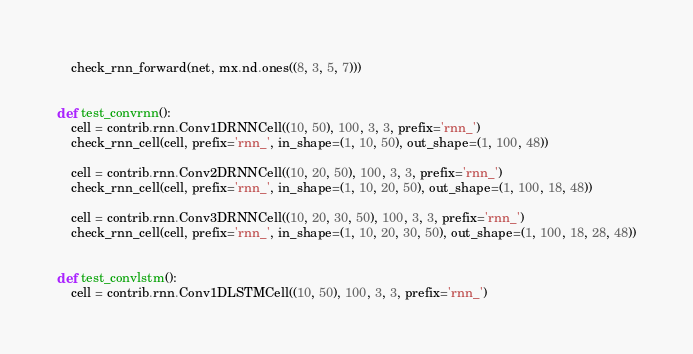<code> <loc_0><loc_0><loc_500><loc_500><_Python_>    check_rnn_forward(net, mx.nd.ones((8, 3, 5, 7)))


def test_convrnn():
    cell = contrib.rnn.Conv1DRNNCell((10, 50), 100, 3, 3, prefix='rnn_')
    check_rnn_cell(cell, prefix='rnn_', in_shape=(1, 10, 50), out_shape=(1, 100, 48))

    cell = contrib.rnn.Conv2DRNNCell((10, 20, 50), 100, 3, 3, prefix='rnn_')
    check_rnn_cell(cell, prefix='rnn_', in_shape=(1, 10, 20, 50), out_shape=(1, 100, 18, 48))

    cell = contrib.rnn.Conv3DRNNCell((10, 20, 30, 50), 100, 3, 3, prefix='rnn_')
    check_rnn_cell(cell, prefix='rnn_', in_shape=(1, 10, 20, 30, 50), out_shape=(1, 100, 18, 28, 48))


def test_convlstm():
    cell = contrib.rnn.Conv1DLSTMCell((10, 50), 100, 3, 3, prefix='rnn_')</code> 